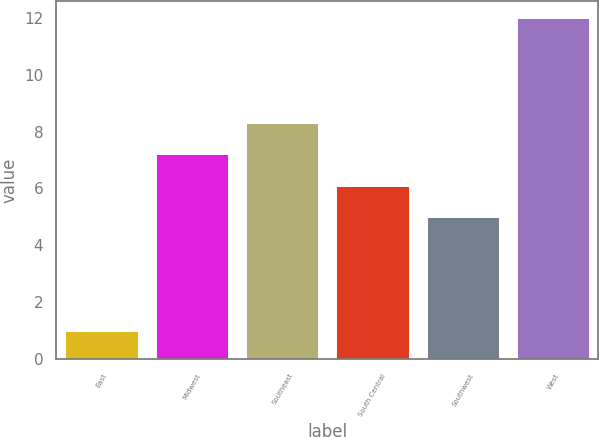<chart> <loc_0><loc_0><loc_500><loc_500><bar_chart><fcel>East<fcel>Midwest<fcel>Southeast<fcel>South Central<fcel>Southwest<fcel>West<nl><fcel>1<fcel>7.2<fcel>8.3<fcel>6.1<fcel>5<fcel>12<nl></chart> 